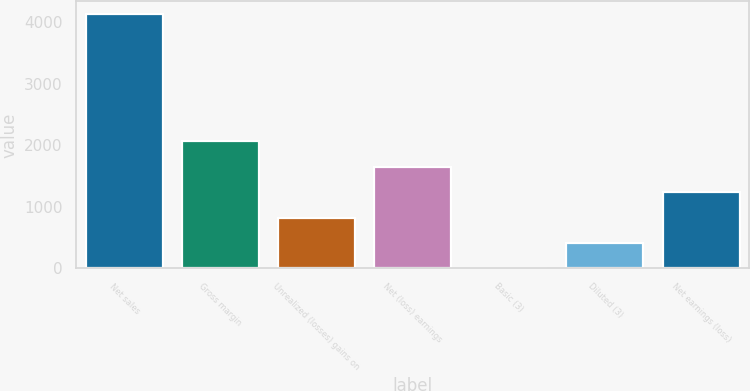Convert chart. <chart><loc_0><loc_0><loc_500><loc_500><bar_chart><fcel>Net sales<fcel>Gross margin<fcel>Unrealized (losses) gains on<fcel>Net (loss) earnings<fcel>Basic (3)<fcel>Diluted (3)<fcel>Net earnings (loss)<nl><fcel>4130<fcel>2065.78<fcel>827.23<fcel>1652.93<fcel>1.53<fcel>414.38<fcel>1240.08<nl></chart> 